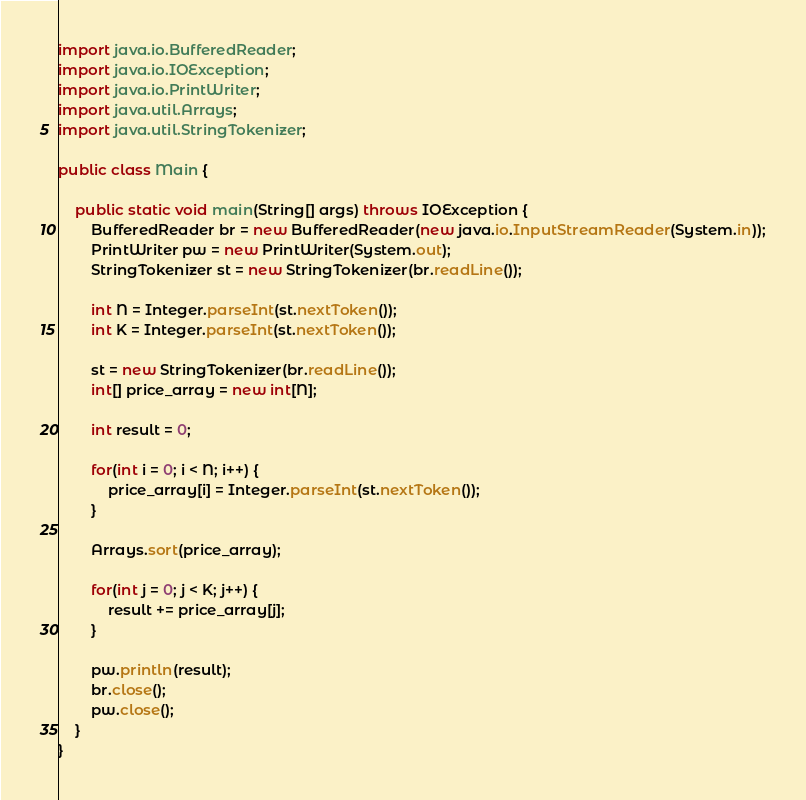<code> <loc_0><loc_0><loc_500><loc_500><_Java_>import java.io.BufferedReader;
import java.io.IOException;
import java.io.PrintWriter;
import java.util.Arrays;
import java.util.StringTokenizer;

public class Main {
    
    public static void main(String[] args) throws IOException {
        BufferedReader br = new BufferedReader(new java.io.InputStreamReader(System.in));
        PrintWriter pw = new PrintWriter(System.out);
        StringTokenizer st = new StringTokenizer(br.readLine());

        int N = Integer.parseInt(st.nextToken());
        int K = Integer.parseInt(st.nextToken());

        st = new StringTokenizer(br.readLine());
        int[] price_array = new int[N];

        int result = 0;

        for(int i = 0; i < N; i++) {
            price_array[i] = Integer.parseInt(st.nextToken());
        }

        Arrays.sort(price_array);

        for(int j = 0; j < K; j++) {
            result += price_array[j];
        }
        
        pw.println(result);
        br.close();
        pw.close();
    }
}</code> 